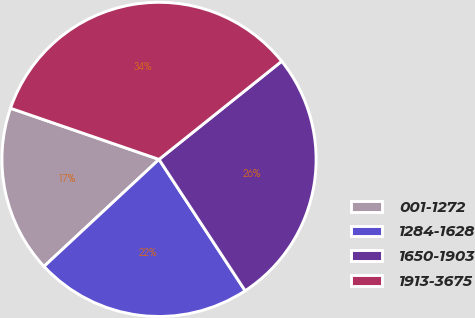Convert chart to OTSL. <chart><loc_0><loc_0><loc_500><loc_500><pie_chart><fcel>001-1272<fcel>1284-1628<fcel>1650-1903<fcel>1913-3675<nl><fcel>17.21%<fcel>22.31%<fcel>26.5%<fcel>33.98%<nl></chart> 